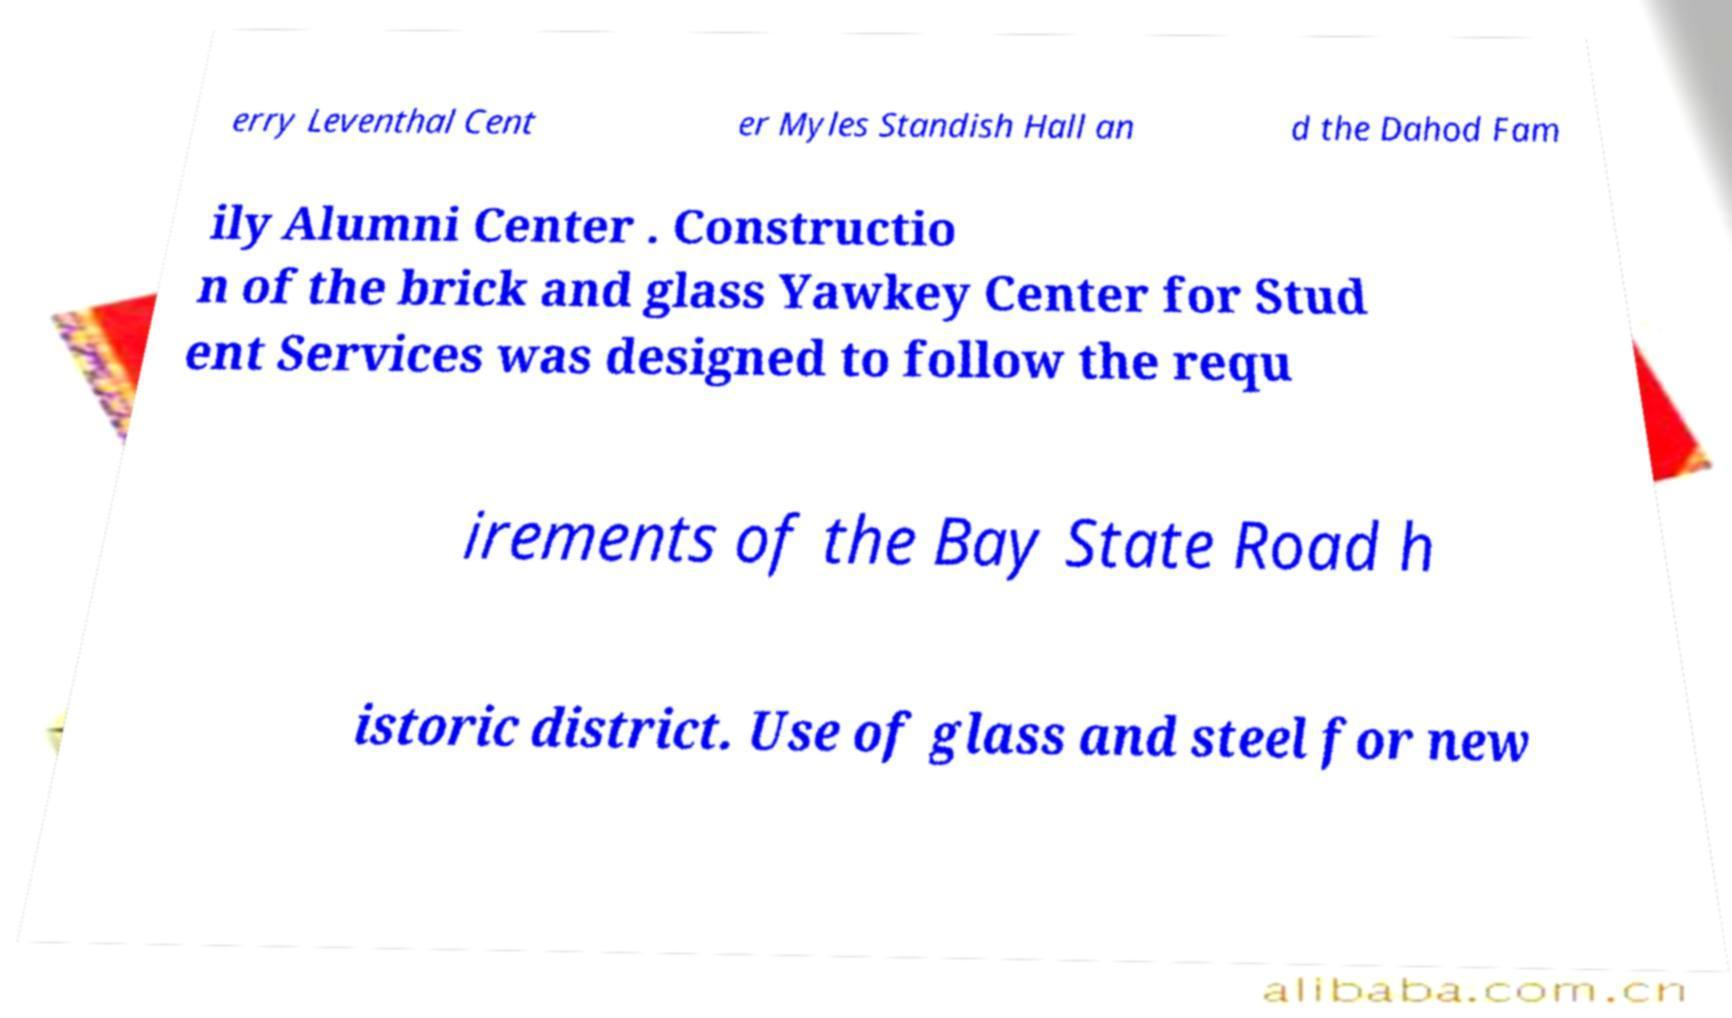Can you read and provide the text displayed in the image?This photo seems to have some interesting text. Can you extract and type it out for me? erry Leventhal Cent er Myles Standish Hall an d the Dahod Fam ily Alumni Center . Constructio n of the brick and glass Yawkey Center for Stud ent Services was designed to follow the requ irements of the Bay State Road h istoric district. Use of glass and steel for new 